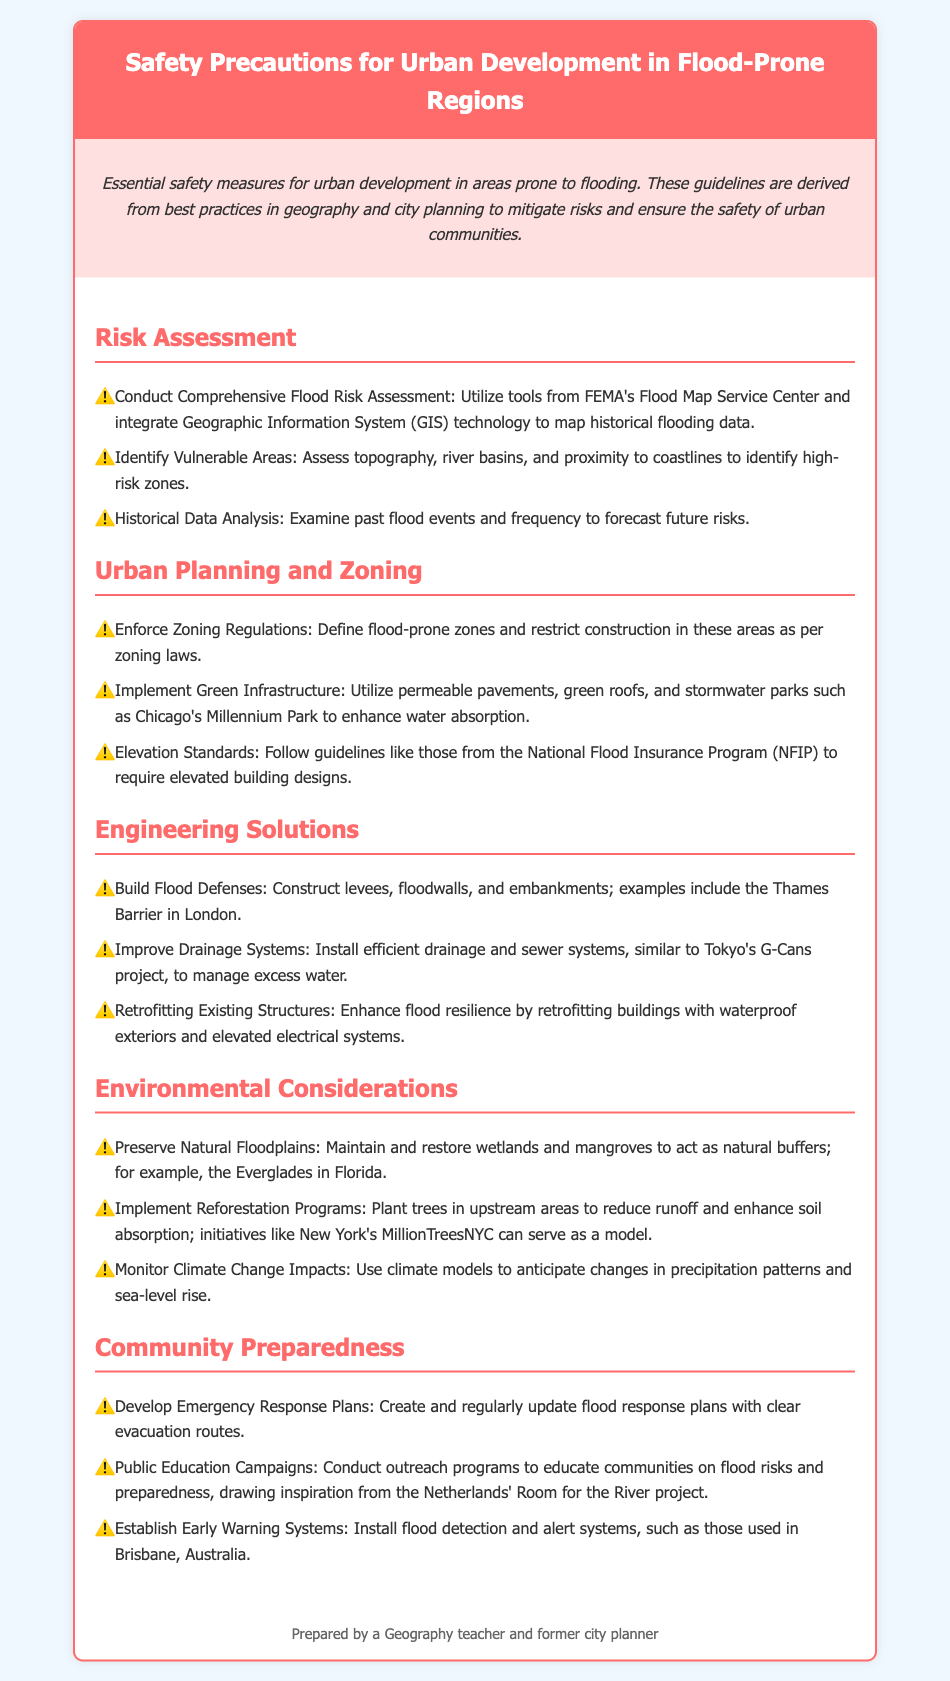What is the title of the document? The title of the document is specified in the header section of the document.
Answer: Safety Precautions for Urban Development in Flood-Prone Regions What technology is suggested for flood risk assessment? The document refers to FEMA's Flood Map Service Center and GIS technology for mapping historical flooding data.
Answer: GIS technology Which natural features should be preserved according to the document? The document mentions maintaining and restoring wetlands and mangroves as natural buffers.
Answer: Wetlands and mangroves What is emphasized in urban planning and zoning? The document underscores the enforcement of zoning regulations to define flood-prone zones.
Answer: Zoning regulations What is the project mentioned for improving drainage systems? The document references the Tokyo's G-Cans project as a model for efficient drainage management.
Answer: G-Cans project How often should flood response plans be updated? The document suggests that emergency response plans should be regularly updated.
Answer: Regularly Which community program is mentioned for public education on flood risks? The document highlights outreach programs inspired by the Netherlands' Room for the River project to educate communities on flood preparedness.
Answer: Room for the River What is the main purpose of the document? The document outlines essential safety measures for urban development in areas prone to flooding.
Answer: Safety measures What is advised for historical data analysis? The document states that examining past flood events and frequency is necessary to forecast future risks.
Answer: Examine past flood events 